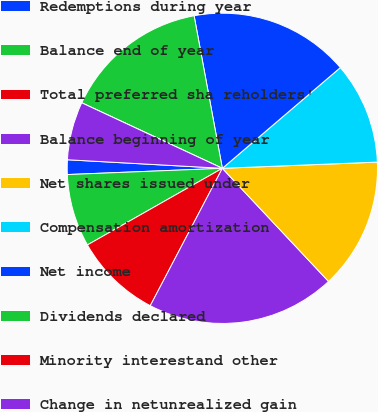<chart> <loc_0><loc_0><loc_500><loc_500><pie_chart><fcel>Redemptions during year<fcel>Balance end of year<fcel>Total preferred sha reholders'<fcel>Balance beginning of year<fcel>Net shares issued under<fcel>Compensation amortization<fcel>Net income<fcel>Dividends declared<fcel>Minority interestand other<fcel>Change in netunrealized gain<nl><fcel>1.52%<fcel>7.58%<fcel>9.09%<fcel>19.69%<fcel>13.64%<fcel>10.61%<fcel>16.67%<fcel>15.15%<fcel>0.0%<fcel>6.06%<nl></chart> 